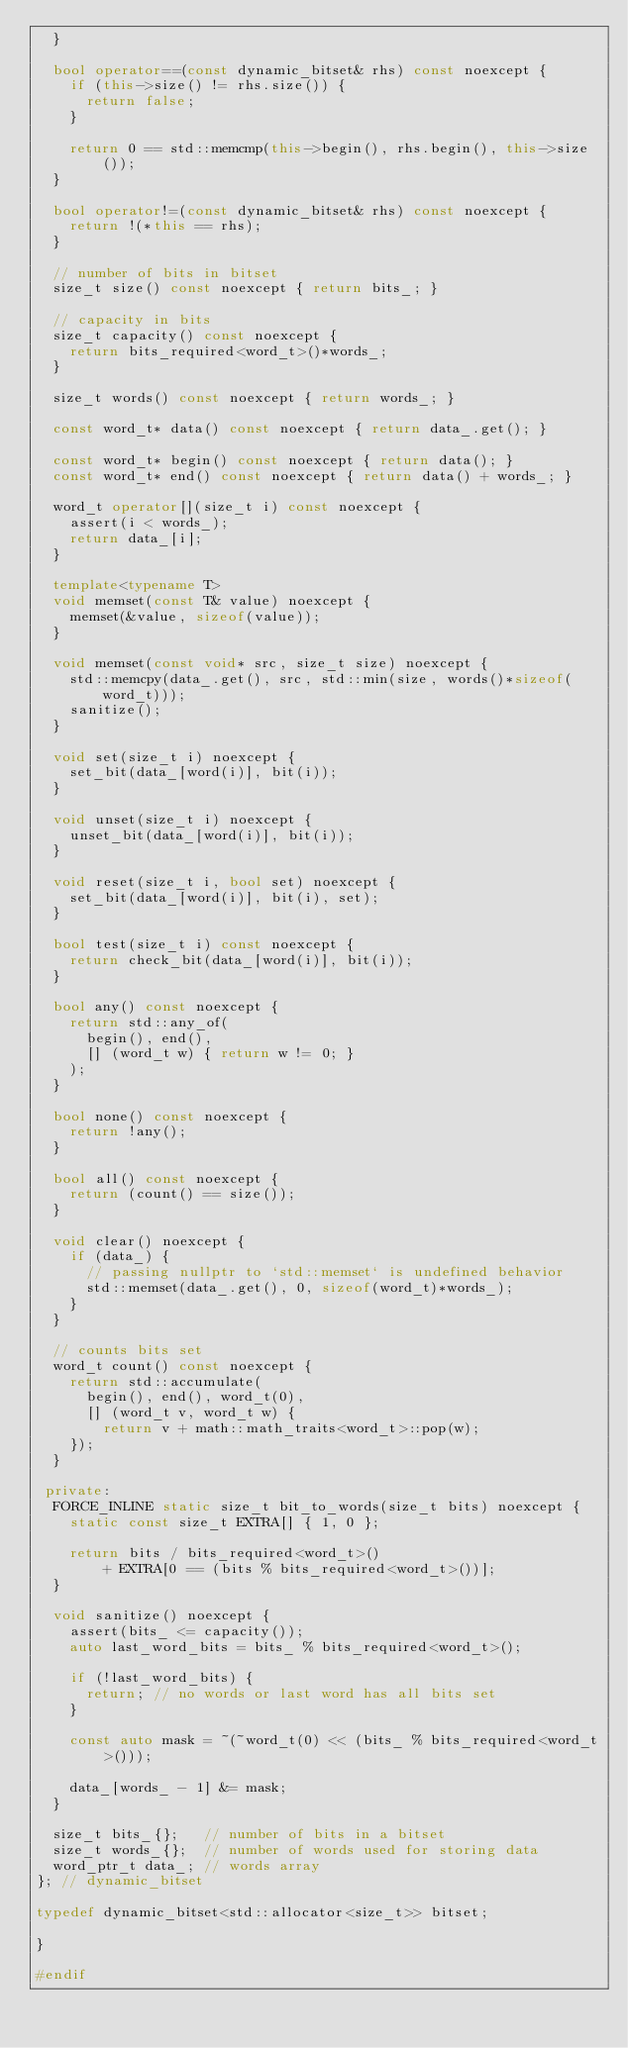<code> <loc_0><loc_0><loc_500><loc_500><_C++_>  }

  bool operator==(const dynamic_bitset& rhs) const noexcept {
    if (this->size() != rhs.size()) {
      return false;
    }

    return 0 == std::memcmp(this->begin(), rhs.begin(), this->size());
  }

  bool operator!=(const dynamic_bitset& rhs) const noexcept {
    return !(*this == rhs);
  }

  // number of bits in bitset
  size_t size() const noexcept { return bits_; }

  // capacity in bits
  size_t capacity() const noexcept {
    return bits_required<word_t>()*words_;
  }

  size_t words() const noexcept { return words_; }

  const word_t* data() const noexcept { return data_.get(); }

  const word_t* begin() const noexcept { return data(); }
  const word_t* end() const noexcept { return data() + words_; }

  word_t operator[](size_t i) const noexcept {
    assert(i < words_);
    return data_[i];
  }

  template<typename T>
  void memset(const T& value) noexcept {
    memset(&value, sizeof(value));
  }

  void memset(const void* src, size_t size) noexcept {
    std::memcpy(data_.get(), src, std::min(size, words()*sizeof(word_t)));
    sanitize();
  }

  void set(size_t i) noexcept {
    set_bit(data_[word(i)], bit(i));
  }

  void unset(size_t i) noexcept {
    unset_bit(data_[word(i)], bit(i));
  }

  void reset(size_t i, bool set) noexcept {
    set_bit(data_[word(i)], bit(i), set);
  }

  bool test(size_t i) const noexcept {
    return check_bit(data_[word(i)], bit(i));
  }

  bool any() const noexcept {
    return std::any_of(
      begin(), end(),
      [] (word_t w) { return w != 0; }
    );
  }

  bool none() const noexcept {
    return !any();
  }

  bool all() const noexcept {
    return (count() == size());
  }

  void clear() noexcept {
    if (data_) {
      // passing nullptr to `std::memset` is undefined behavior
      std::memset(data_.get(), 0, sizeof(word_t)*words_);
    }
  }

  // counts bits set
  word_t count() const noexcept {
    return std::accumulate(
      begin(), end(), word_t(0),
      [] (word_t v, word_t w) {
        return v + math::math_traits<word_t>::pop(w);
    });
  }

 private:
  FORCE_INLINE static size_t bit_to_words(size_t bits) noexcept {
    static const size_t EXTRA[] { 1, 0 };

    return bits / bits_required<word_t>()
        + EXTRA[0 == (bits % bits_required<word_t>())];
  }

  void sanitize() noexcept {
    assert(bits_ <= capacity());
    auto last_word_bits = bits_ % bits_required<word_t>();

    if (!last_word_bits) {
      return; // no words or last word has all bits set
    }

    const auto mask = ~(~word_t(0) << (bits_ % bits_required<word_t>()));

    data_[words_ - 1] &= mask;
  }

  size_t bits_{};   // number of bits in a bitset
  size_t words_{};  // number of words used for storing data
  word_ptr_t data_; // words array
}; // dynamic_bitset

typedef dynamic_bitset<std::allocator<size_t>> bitset;

}

#endif
</code> 